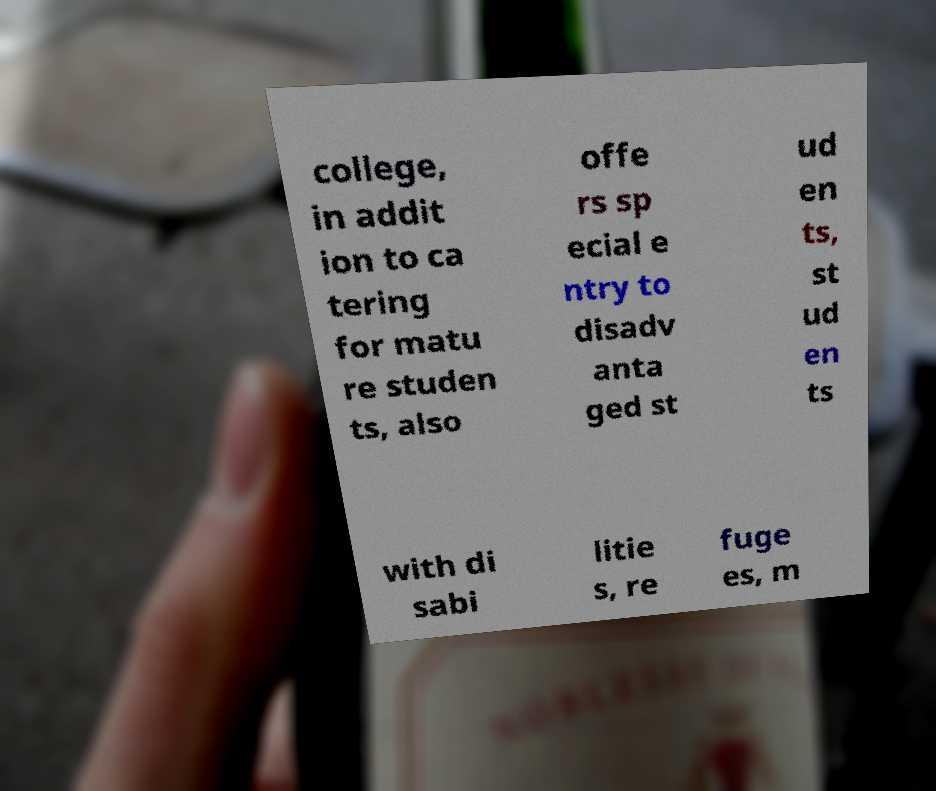For documentation purposes, I need the text within this image transcribed. Could you provide that? college, in addit ion to ca tering for matu re studen ts, also offe rs sp ecial e ntry to disadv anta ged st ud en ts, st ud en ts with di sabi litie s, re fuge es, m 